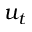<formula> <loc_0><loc_0><loc_500><loc_500>u _ { t }</formula> 